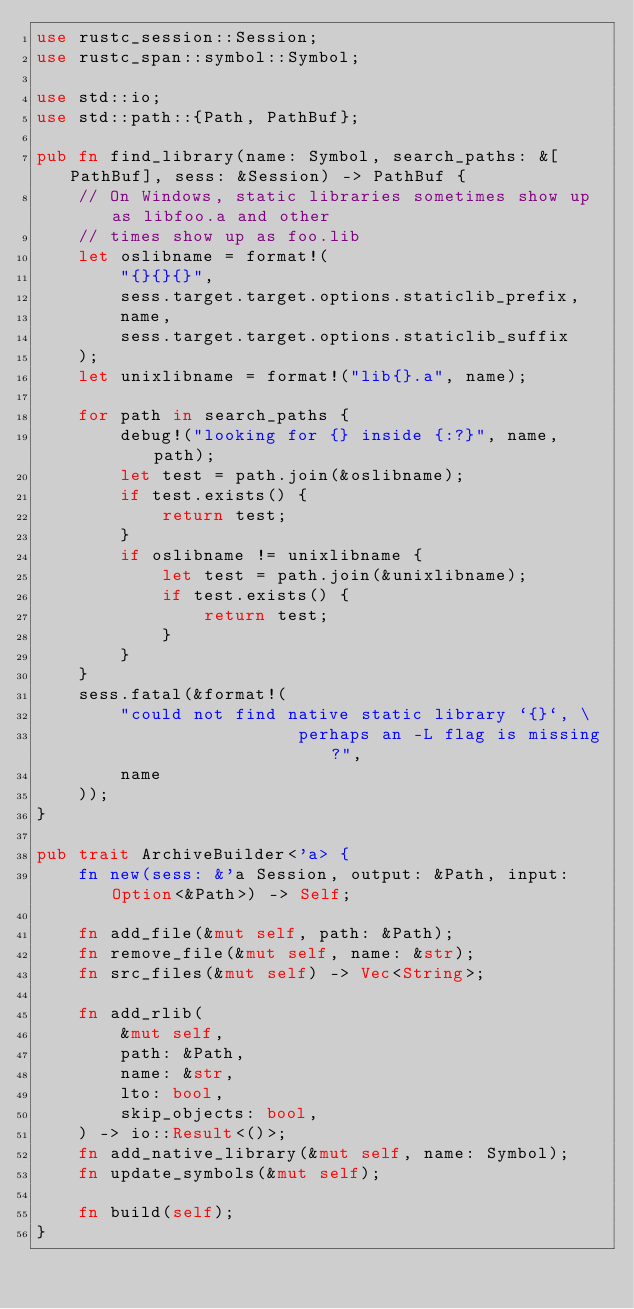<code> <loc_0><loc_0><loc_500><loc_500><_Rust_>use rustc_session::Session;
use rustc_span::symbol::Symbol;

use std::io;
use std::path::{Path, PathBuf};

pub fn find_library(name: Symbol, search_paths: &[PathBuf], sess: &Session) -> PathBuf {
    // On Windows, static libraries sometimes show up as libfoo.a and other
    // times show up as foo.lib
    let oslibname = format!(
        "{}{}{}",
        sess.target.target.options.staticlib_prefix,
        name,
        sess.target.target.options.staticlib_suffix
    );
    let unixlibname = format!("lib{}.a", name);

    for path in search_paths {
        debug!("looking for {} inside {:?}", name, path);
        let test = path.join(&oslibname);
        if test.exists() {
            return test;
        }
        if oslibname != unixlibname {
            let test = path.join(&unixlibname);
            if test.exists() {
                return test;
            }
        }
    }
    sess.fatal(&format!(
        "could not find native static library `{}`, \
                         perhaps an -L flag is missing?",
        name
    ));
}

pub trait ArchiveBuilder<'a> {
    fn new(sess: &'a Session, output: &Path, input: Option<&Path>) -> Self;

    fn add_file(&mut self, path: &Path);
    fn remove_file(&mut self, name: &str);
    fn src_files(&mut self) -> Vec<String>;

    fn add_rlib(
        &mut self,
        path: &Path,
        name: &str,
        lto: bool,
        skip_objects: bool,
    ) -> io::Result<()>;
    fn add_native_library(&mut self, name: Symbol);
    fn update_symbols(&mut self);

    fn build(self);
}
</code> 